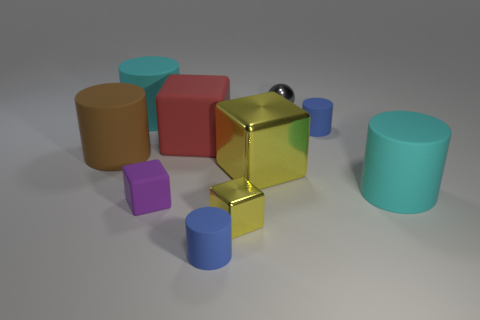How many things are either rubber objects that are on the left side of the purple rubber object or cyan rubber things that are on the left side of the tiny purple matte block?
Ensure brevity in your answer.  2. What number of other objects are there of the same color as the big shiny object?
Provide a succinct answer. 1. Are there more blue cylinders that are to the left of the gray shiny sphere than big metallic cubes on the left side of the big yellow metal thing?
Your response must be concise. Yes. What number of cylinders are either large cyan matte things or brown things?
Keep it short and to the point. 3. How many things are blue rubber things left of the big yellow thing or tiny green matte cubes?
Offer a very short reply. 1. There is a small blue thing in front of the object that is on the left side of the large matte cylinder behind the large brown rubber cylinder; what shape is it?
Keep it short and to the point. Cylinder. How many tiny yellow metal objects are the same shape as the red object?
Your response must be concise. 1. There is a big thing that is the same color as the small metal cube; what is it made of?
Provide a short and direct response. Metal. Is the material of the purple thing the same as the big yellow cube?
Offer a very short reply. No. What number of large rubber cylinders are to the right of the large cyan matte object that is behind the big matte cylinder that is right of the tiny ball?
Keep it short and to the point. 1. 